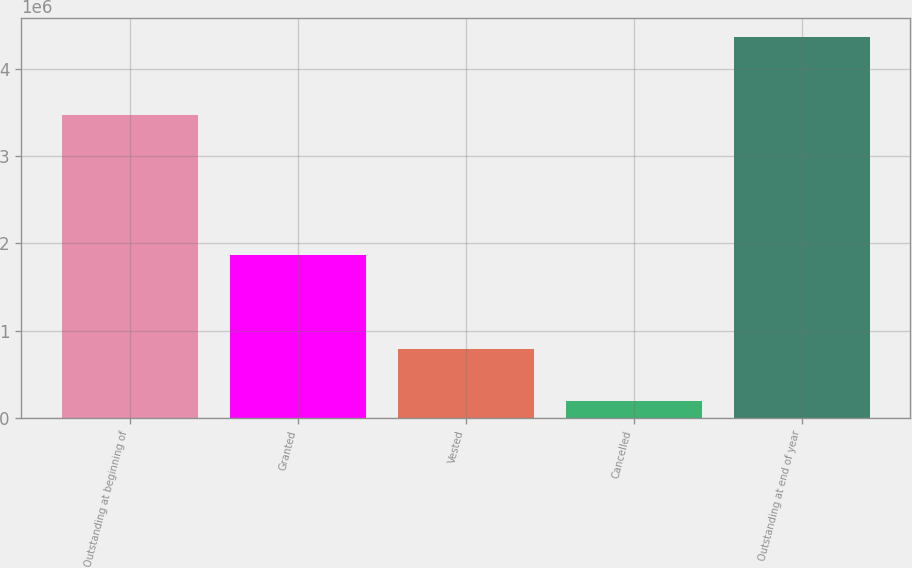Convert chart to OTSL. <chart><loc_0><loc_0><loc_500><loc_500><bar_chart><fcel>Outstanding at beginning of<fcel>Granted<fcel>Vested<fcel>Cancelled<fcel>Outstanding at end of year<nl><fcel>3.47823e+06<fcel>1.86866e+06<fcel>792941<fcel>188170<fcel>4.36578e+06<nl></chart> 